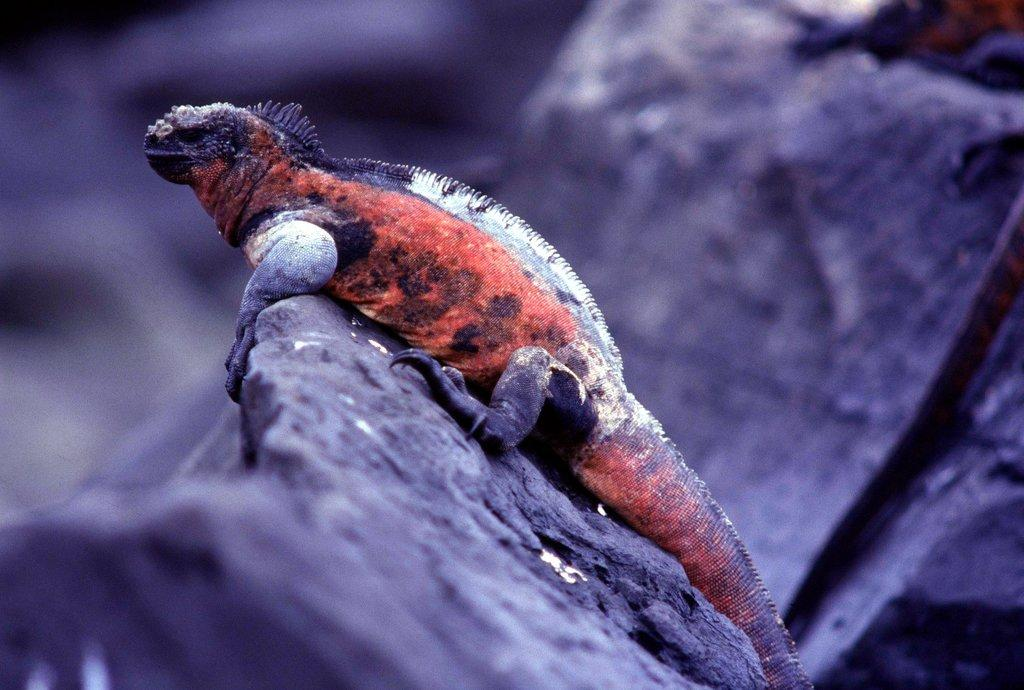What type of animal is in the image? There is a chameleon in the image. What is the chameleon resting on? The chameleon is on rocks. What colors can be seen on the chameleon? The chameleon has red, black, and white coloration. What type of fruit is the chameleon holding in the image? There is no fruit present in the image, and the chameleon is not holding anything. 